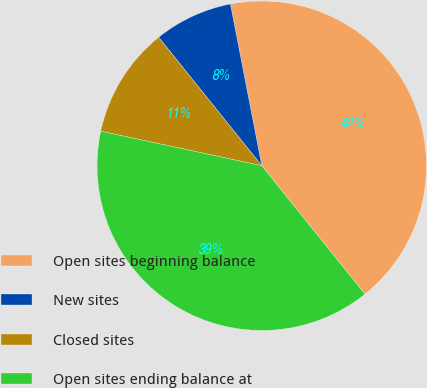Convert chart. <chart><loc_0><loc_0><loc_500><loc_500><pie_chart><fcel>Open sites beginning balance<fcel>New sites<fcel>Closed sites<fcel>Open sites ending balance at<nl><fcel>42.28%<fcel>7.72%<fcel>10.87%<fcel>39.13%<nl></chart> 